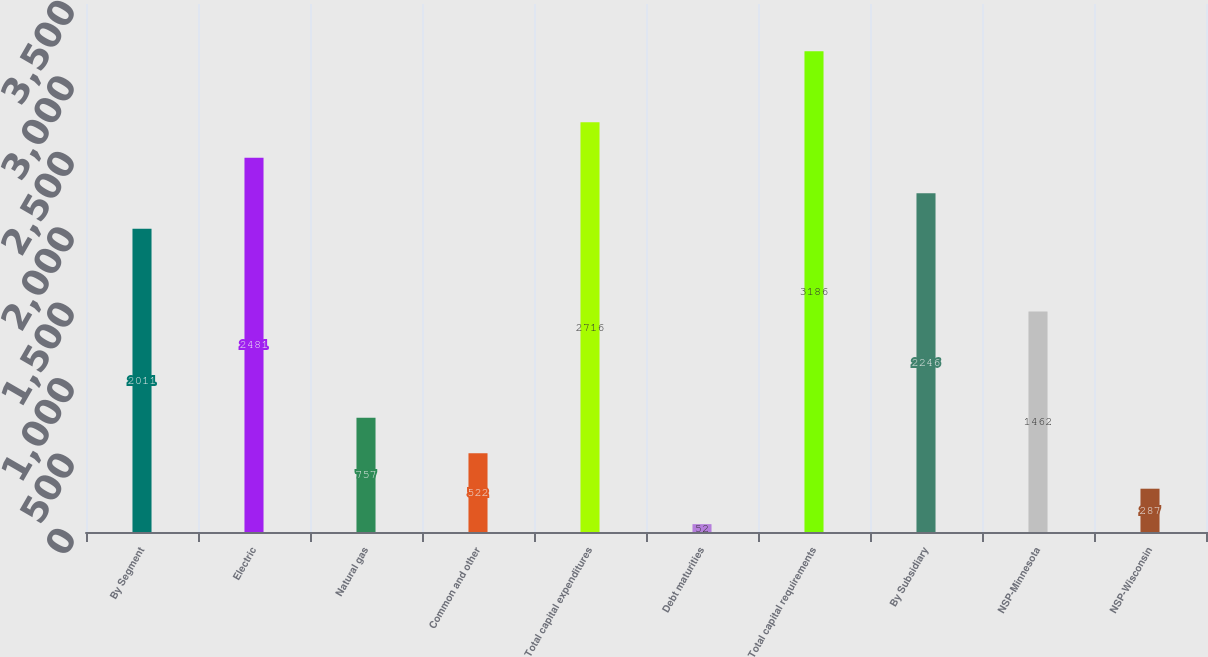<chart> <loc_0><loc_0><loc_500><loc_500><bar_chart><fcel>By Segment<fcel>Electric<fcel>Natural gas<fcel>Common and other<fcel>Total capital expenditures<fcel>Debt maturities<fcel>Total capital requirements<fcel>By Subsidiary<fcel>NSP-Minnesota<fcel>NSP-Wisconsin<nl><fcel>2011<fcel>2481<fcel>757<fcel>522<fcel>2716<fcel>52<fcel>3186<fcel>2246<fcel>1462<fcel>287<nl></chart> 